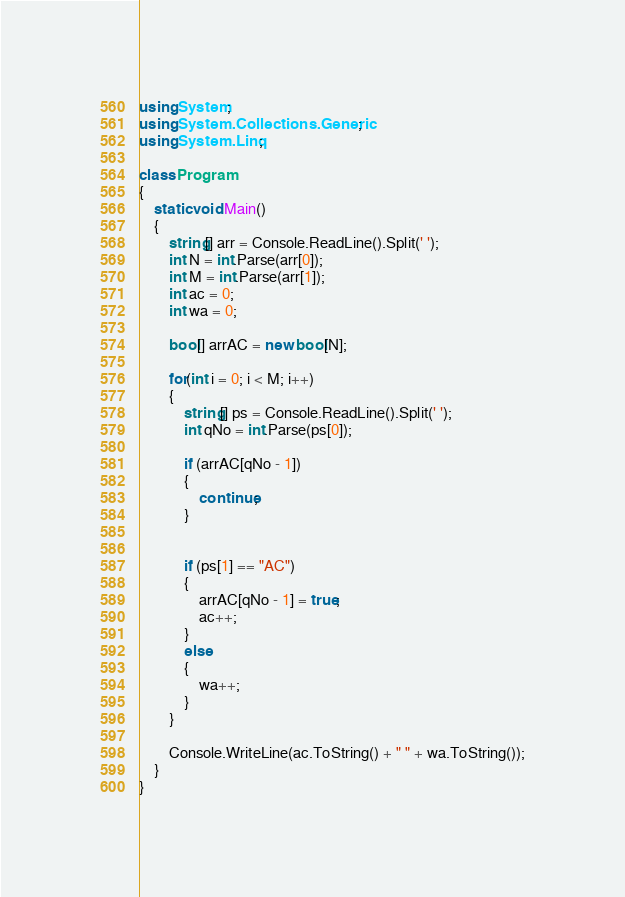<code> <loc_0><loc_0><loc_500><loc_500><_C#_>using System;
using System.Collections.Generic;
using System.Linq;

class Program
{
    static void Main()
    {
        string[] arr = Console.ReadLine().Split(' ');
        int N = int.Parse(arr[0]);
        int M = int.Parse(arr[1]);
        int ac = 0;
        int wa = 0;

        bool[] arrAC = new bool[N];

        for(int i = 0; i < M; i++)
        {
            string[] ps = Console.ReadLine().Split(' ');
            int qNo = int.Parse(ps[0]);

            if (arrAC[qNo - 1])
            {
                continue;
            }


            if (ps[1] == "AC")
            {
                arrAC[qNo - 1] = true;
                ac++;
            }
            else
            {
                wa++;
            }
        }

        Console.WriteLine(ac.ToString() + " " + wa.ToString());
    }
}</code> 